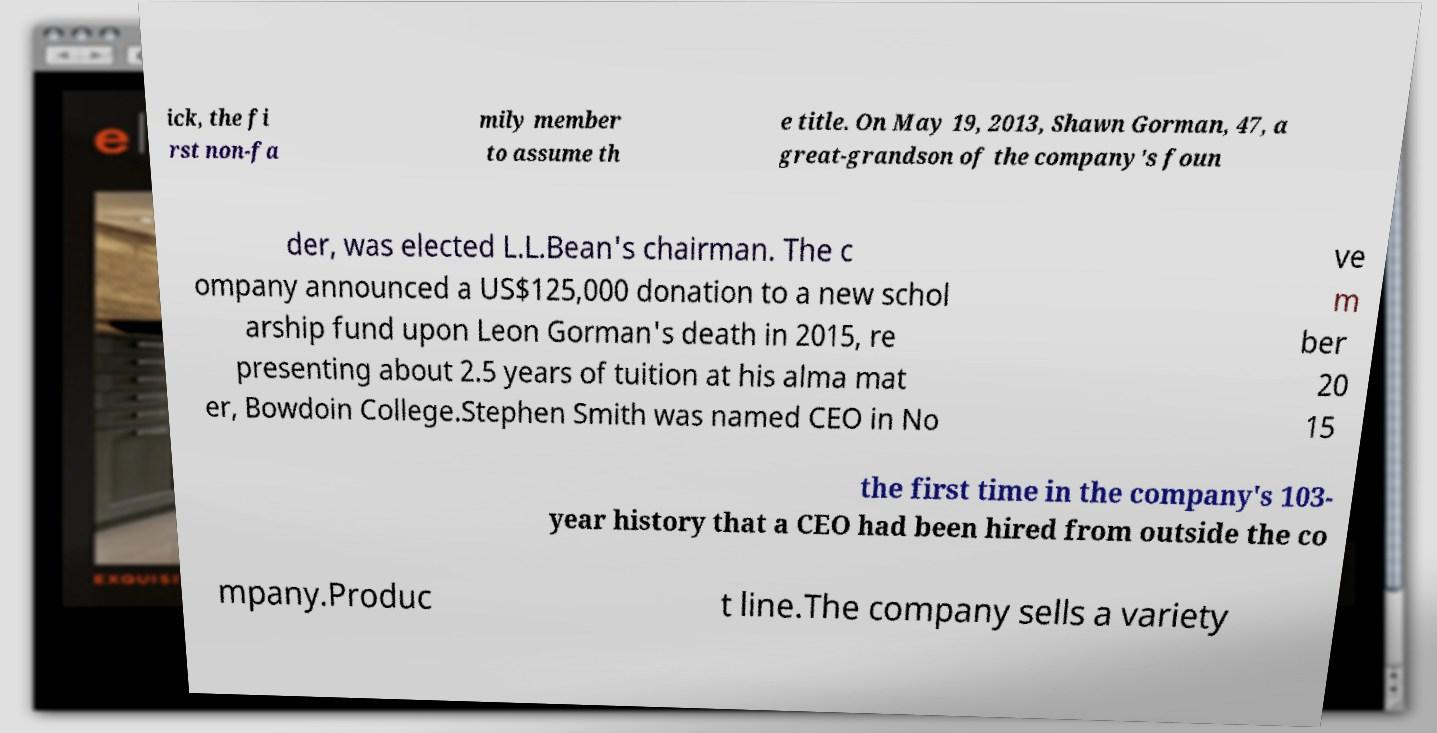There's text embedded in this image that I need extracted. Can you transcribe it verbatim? ick, the fi rst non-fa mily member to assume th e title. On May 19, 2013, Shawn Gorman, 47, a great-grandson of the company's foun der, was elected L.L.Bean's chairman. The c ompany announced a US$125,000 donation to a new schol arship fund upon Leon Gorman's death in 2015, re presenting about 2.5 years of tuition at his alma mat er, Bowdoin College.Stephen Smith was named CEO in No ve m ber 20 15 the first time in the company's 103- year history that a CEO had been hired from outside the co mpany.Produc t line.The company sells a variety 